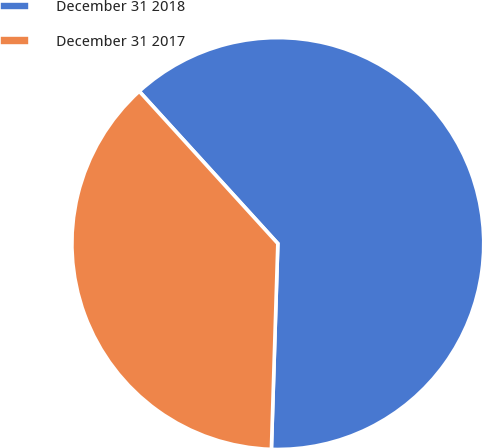<chart> <loc_0><loc_0><loc_500><loc_500><pie_chart><fcel>December 31 2018<fcel>December 31 2017<nl><fcel>62.25%<fcel>37.75%<nl></chart> 